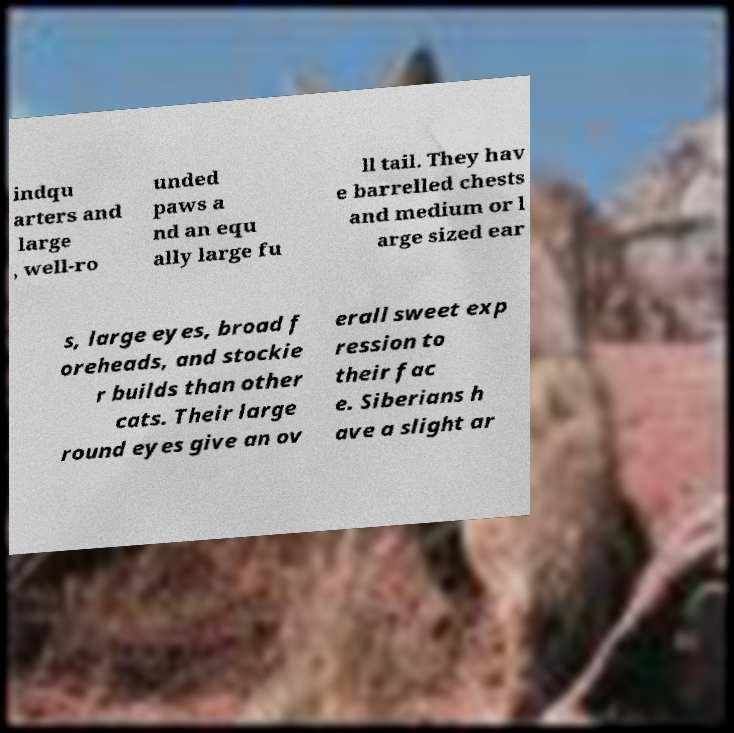Could you assist in decoding the text presented in this image and type it out clearly? indqu arters and large , well-ro unded paws a nd an equ ally large fu ll tail. They hav e barrelled chests and medium or l arge sized ear s, large eyes, broad f oreheads, and stockie r builds than other cats. Their large round eyes give an ov erall sweet exp ression to their fac e. Siberians h ave a slight ar 